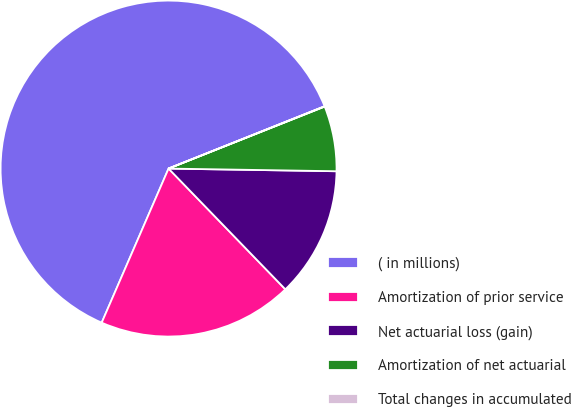<chart> <loc_0><loc_0><loc_500><loc_500><pie_chart><fcel>( in millions)<fcel>Amortization of prior service<fcel>Net actuarial loss (gain)<fcel>Amortization of net actuarial<fcel>Total changes in accumulated<nl><fcel>62.43%<fcel>18.75%<fcel>12.51%<fcel>6.27%<fcel>0.03%<nl></chart> 